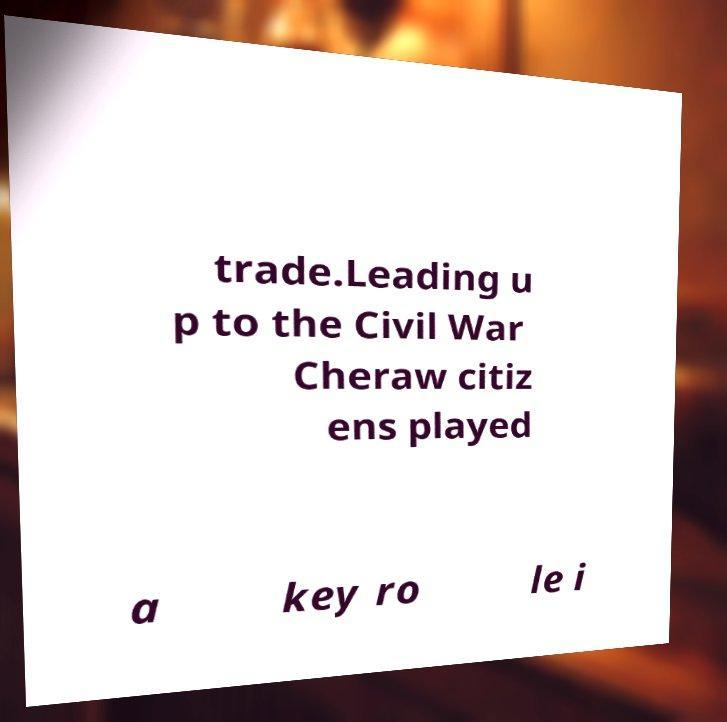Could you assist in decoding the text presented in this image and type it out clearly? trade.Leading u p to the Civil War Cheraw citiz ens played a key ro le i 